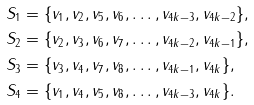Convert formula to latex. <formula><loc_0><loc_0><loc_500><loc_500>S _ { 1 } & = \{ v _ { 1 } , v _ { 2 } , v _ { 5 } , v _ { 6 } , \dots , v _ { 4 k - 3 } , v _ { 4 k - 2 } \} , \\ S _ { 2 } & = \{ v _ { 2 } , v _ { 3 } , v _ { 6 } , v _ { 7 } , \dots , v _ { 4 k - 2 } , v _ { 4 k - 1 } \} , \\ S _ { 3 } & = \{ v _ { 3 } , v _ { 4 } , v _ { 7 } , v _ { 8 } , \dots , v _ { 4 k - 1 } , v _ { 4 k } \} , \\ S _ { 4 } & = \{ v _ { 1 } , v _ { 4 } , v _ { 5 } , v _ { 8 } , \dots , v _ { 4 k - 3 } , v _ { 4 k } \} .</formula> 